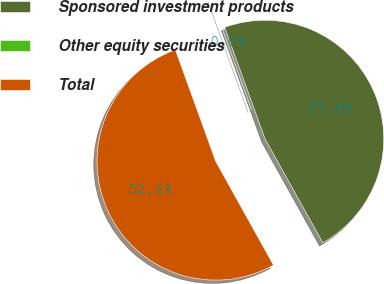<chart> <loc_0><loc_0><loc_500><loc_500><pie_chart><fcel>Sponsored investment products<fcel>Other equity securities<fcel>Total<nl><fcel>47.44%<fcel>0.0%<fcel>52.56%<nl></chart> 